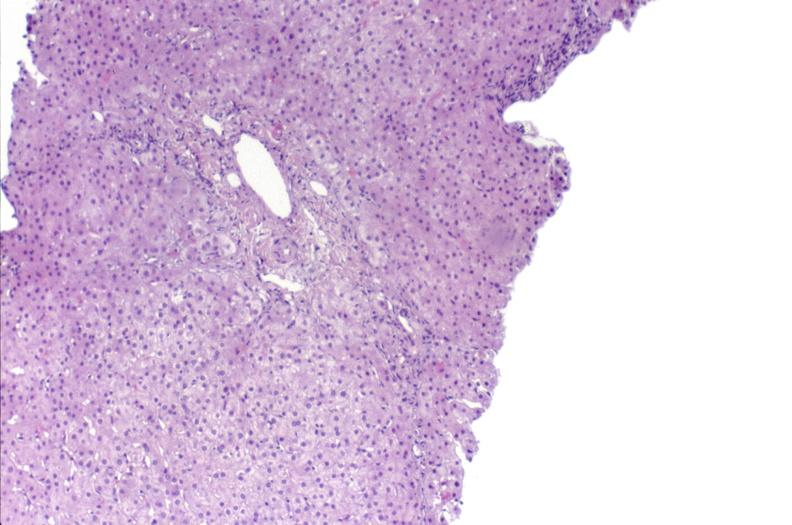what is present?
Answer the question using a single word or phrase. Liver 